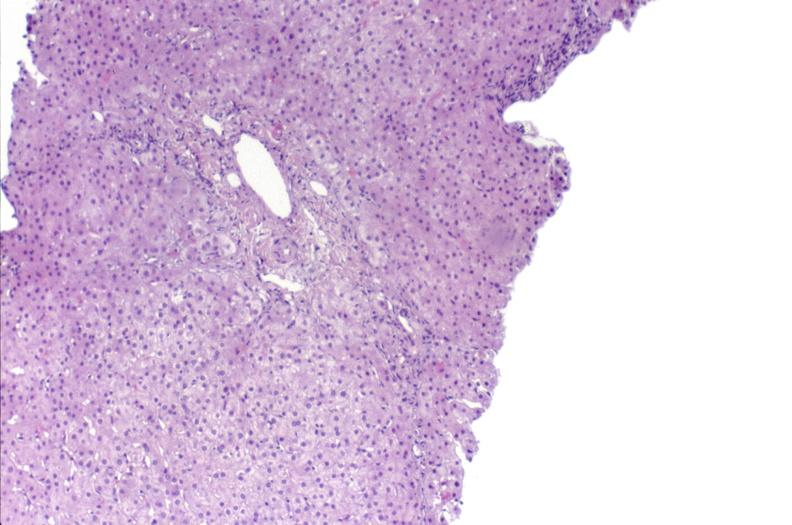what is present?
Answer the question using a single word or phrase. Liver 